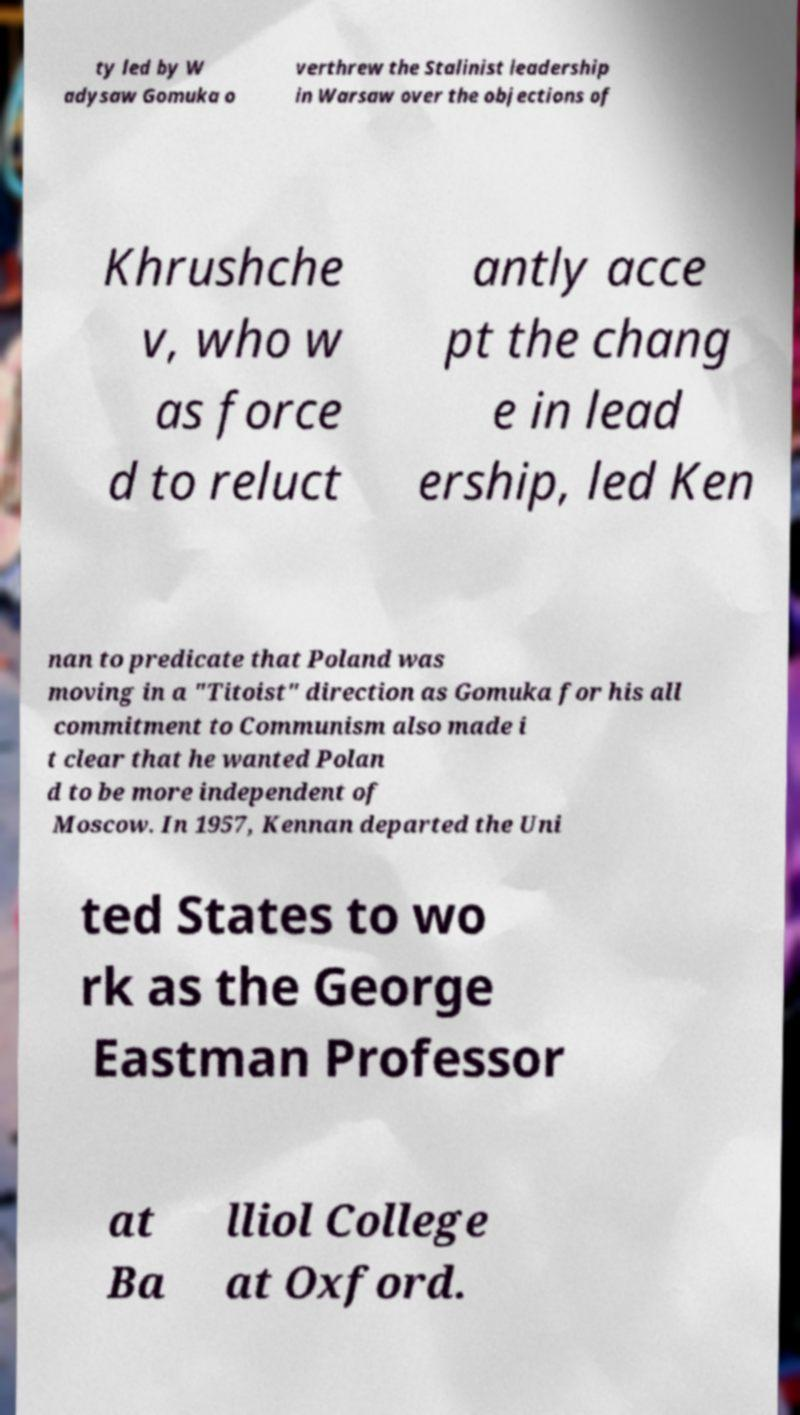Can you read and provide the text displayed in the image?This photo seems to have some interesting text. Can you extract and type it out for me? ty led by W adysaw Gomuka o verthrew the Stalinist leadership in Warsaw over the objections of Khrushche v, who w as force d to reluct antly acce pt the chang e in lead ership, led Ken nan to predicate that Poland was moving in a "Titoist" direction as Gomuka for his all commitment to Communism also made i t clear that he wanted Polan d to be more independent of Moscow. In 1957, Kennan departed the Uni ted States to wo rk as the George Eastman Professor at Ba lliol College at Oxford. 